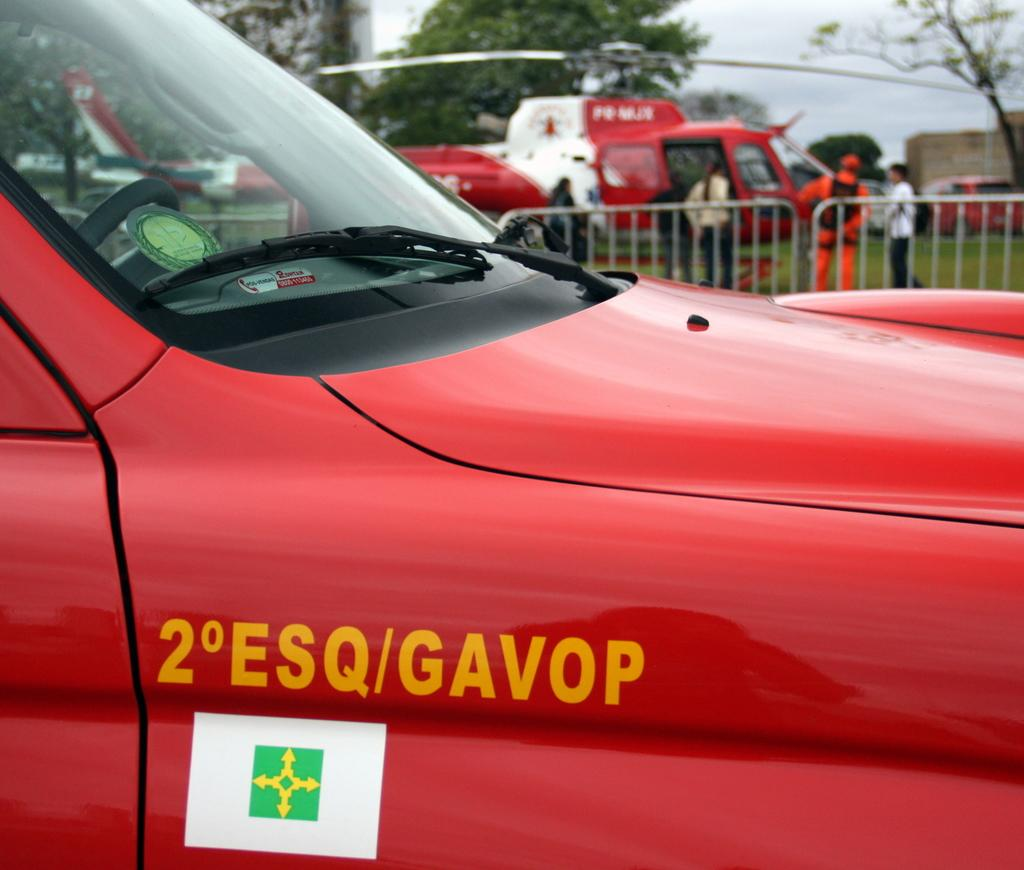<image>
Render a clear and concise summary of the photo. A red vehicle with the word Gavop written in yellow on it. 